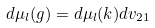<formula> <loc_0><loc_0><loc_500><loc_500>d \mu _ { l } ( g ) = d \mu _ { l } ( k ) d v _ { 2 1 }</formula> 